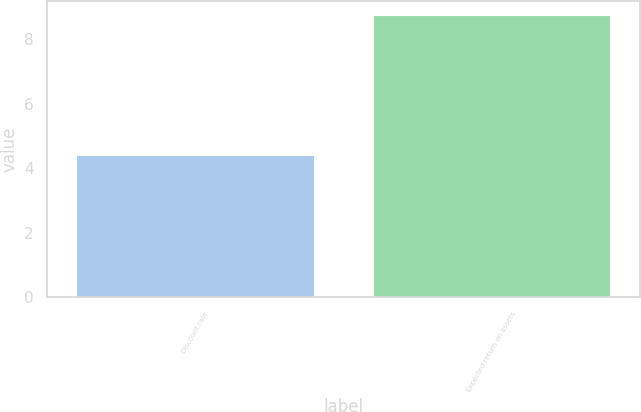Convert chart to OTSL. <chart><loc_0><loc_0><loc_500><loc_500><bar_chart><fcel>Discount rate<fcel>Expected return on assets<nl><fcel>4.42<fcel>8.75<nl></chart> 